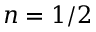Convert formula to latex. <formula><loc_0><loc_0><loc_500><loc_500>n = 1 / 2</formula> 